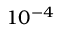Convert formula to latex. <formula><loc_0><loc_0><loc_500><loc_500>1 0 ^ { - 4 }</formula> 